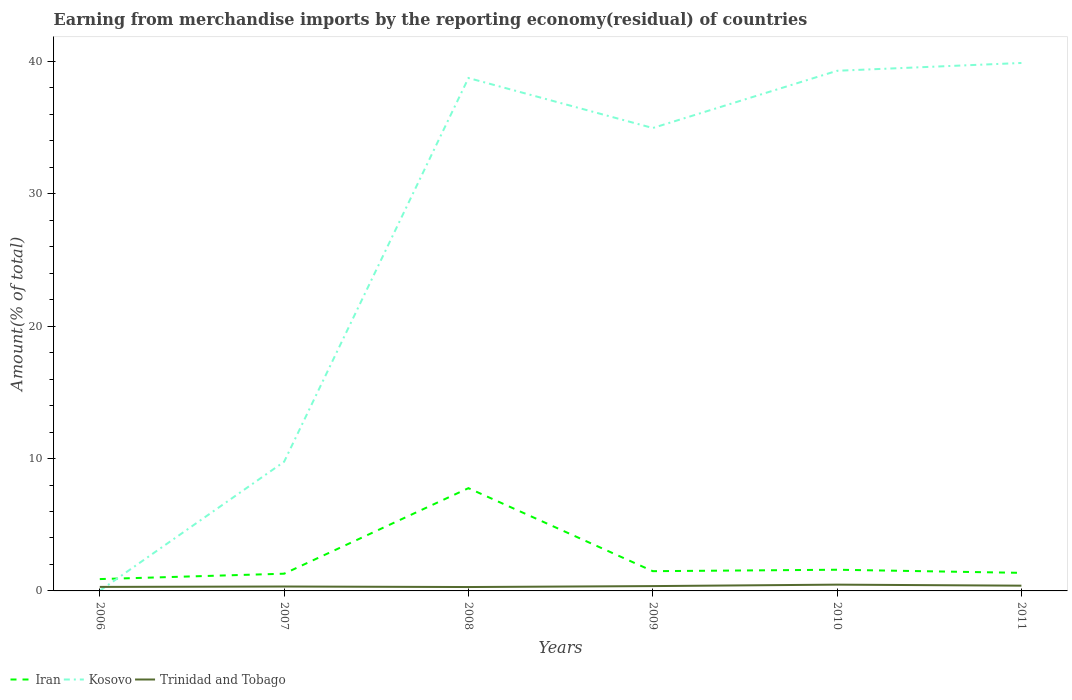Does the line corresponding to Iran intersect with the line corresponding to Trinidad and Tobago?
Offer a terse response. No. Is the number of lines equal to the number of legend labels?
Provide a short and direct response. Yes. Across all years, what is the maximum percentage of amount earned from merchandise imports in Iran?
Your answer should be very brief. 0.89. In which year was the percentage of amount earned from merchandise imports in Kosovo maximum?
Make the answer very short. 2006. What is the total percentage of amount earned from merchandise imports in Kosovo in the graph?
Offer a very short reply. -34.95. What is the difference between the highest and the second highest percentage of amount earned from merchandise imports in Kosovo?
Your answer should be compact. 39.87. How many lines are there?
Offer a very short reply. 3. What is the difference between two consecutive major ticks on the Y-axis?
Your answer should be compact. 10. Are the values on the major ticks of Y-axis written in scientific E-notation?
Offer a very short reply. No. Does the graph contain any zero values?
Your answer should be compact. No. Where does the legend appear in the graph?
Provide a short and direct response. Bottom left. What is the title of the graph?
Offer a very short reply. Earning from merchandise imports by the reporting economy(residual) of countries. Does "Dominican Republic" appear as one of the legend labels in the graph?
Give a very brief answer. No. What is the label or title of the Y-axis?
Make the answer very short. Amount(% of total). What is the Amount(% of total) of Iran in 2006?
Offer a very short reply. 0.89. What is the Amount(% of total) of Kosovo in 2006?
Give a very brief answer. 0.01. What is the Amount(% of total) of Trinidad and Tobago in 2006?
Make the answer very short. 0.3. What is the Amount(% of total) of Iran in 2007?
Offer a terse response. 1.3. What is the Amount(% of total) of Kosovo in 2007?
Your answer should be very brief. 9.76. What is the Amount(% of total) in Trinidad and Tobago in 2007?
Make the answer very short. 0.33. What is the Amount(% of total) in Iran in 2008?
Provide a succinct answer. 7.76. What is the Amount(% of total) of Kosovo in 2008?
Provide a succinct answer. 38.74. What is the Amount(% of total) of Trinidad and Tobago in 2008?
Ensure brevity in your answer.  0.29. What is the Amount(% of total) of Iran in 2009?
Your response must be concise. 1.49. What is the Amount(% of total) in Kosovo in 2009?
Offer a terse response. 34.97. What is the Amount(% of total) in Trinidad and Tobago in 2009?
Give a very brief answer. 0.36. What is the Amount(% of total) in Iran in 2010?
Offer a terse response. 1.6. What is the Amount(% of total) of Kosovo in 2010?
Give a very brief answer. 39.29. What is the Amount(% of total) of Trinidad and Tobago in 2010?
Ensure brevity in your answer.  0.47. What is the Amount(% of total) of Iran in 2011?
Your response must be concise. 1.36. What is the Amount(% of total) in Kosovo in 2011?
Keep it short and to the point. 39.88. What is the Amount(% of total) of Trinidad and Tobago in 2011?
Ensure brevity in your answer.  0.4. Across all years, what is the maximum Amount(% of total) of Iran?
Offer a terse response. 7.76. Across all years, what is the maximum Amount(% of total) of Kosovo?
Provide a short and direct response. 39.88. Across all years, what is the maximum Amount(% of total) in Trinidad and Tobago?
Your answer should be compact. 0.47. Across all years, what is the minimum Amount(% of total) in Iran?
Your answer should be very brief. 0.89. Across all years, what is the minimum Amount(% of total) of Kosovo?
Make the answer very short. 0.01. Across all years, what is the minimum Amount(% of total) in Trinidad and Tobago?
Provide a short and direct response. 0.29. What is the total Amount(% of total) in Iran in the graph?
Make the answer very short. 14.41. What is the total Amount(% of total) in Kosovo in the graph?
Your answer should be very brief. 162.65. What is the total Amount(% of total) of Trinidad and Tobago in the graph?
Your answer should be very brief. 2.17. What is the difference between the Amount(% of total) in Iran in 2006 and that in 2007?
Ensure brevity in your answer.  -0.41. What is the difference between the Amount(% of total) in Kosovo in 2006 and that in 2007?
Offer a terse response. -9.74. What is the difference between the Amount(% of total) in Trinidad and Tobago in 2006 and that in 2007?
Your response must be concise. -0.03. What is the difference between the Amount(% of total) in Iran in 2006 and that in 2008?
Give a very brief answer. -6.87. What is the difference between the Amount(% of total) of Kosovo in 2006 and that in 2008?
Offer a terse response. -38.73. What is the difference between the Amount(% of total) of Trinidad and Tobago in 2006 and that in 2008?
Your response must be concise. 0.01. What is the difference between the Amount(% of total) of Iran in 2006 and that in 2009?
Offer a very short reply. -0.6. What is the difference between the Amount(% of total) of Kosovo in 2006 and that in 2009?
Offer a terse response. -34.95. What is the difference between the Amount(% of total) in Trinidad and Tobago in 2006 and that in 2009?
Your answer should be very brief. -0.06. What is the difference between the Amount(% of total) of Iran in 2006 and that in 2010?
Ensure brevity in your answer.  -0.71. What is the difference between the Amount(% of total) of Kosovo in 2006 and that in 2010?
Offer a very short reply. -39.28. What is the difference between the Amount(% of total) in Trinidad and Tobago in 2006 and that in 2010?
Your response must be concise. -0.17. What is the difference between the Amount(% of total) in Iran in 2006 and that in 2011?
Offer a terse response. -0.47. What is the difference between the Amount(% of total) of Kosovo in 2006 and that in 2011?
Your answer should be very brief. -39.87. What is the difference between the Amount(% of total) in Trinidad and Tobago in 2006 and that in 2011?
Your answer should be compact. -0.09. What is the difference between the Amount(% of total) of Iran in 2007 and that in 2008?
Your answer should be very brief. -6.46. What is the difference between the Amount(% of total) in Kosovo in 2007 and that in 2008?
Your answer should be compact. -28.99. What is the difference between the Amount(% of total) in Trinidad and Tobago in 2007 and that in 2008?
Offer a terse response. 0.04. What is the difference between the Amount(% of total) of Iran in 2007 and that in 2009?
Your response must be concise. -0.19. What is the difference between the Amount(% of total) in Kosovo in 2007 and that in 2009?
Make the answer very short. -25.21. What is the difference between the Amount(% of total) of Trinidad and Tobago in 2007 and that in 2009?
Provide a short and direct response. -0.03. What is the difference between the Amount(% of total) of Iran in 2007 and that in 2010?
Offer a terse response. -0.3. What is the difference between the Amount(% of total) of Kosovo in 2007 and that in 2010?
Keep it short and to the point. -29.53. What is the difference between the Amount(% of total) in Trinidad and Tobago in 2007 and that in 2010?
Provide a short and direct response. -0.14. What is the difference between the Amount(% of total) in Iran in 2007 and that in 2011?
Offer a terse response. -0.06. What is the difference between the Amount(% of total) in Kosovo in 2007 and that in 2011?
Ensure brevity in your answer.  -30.12. What is the difference between the Amount(% of total) in Trinidad and Tobago in 2007 and that in 2011?
Your response must be concise. -0.06. What is the difference between the Amount(% of total) of Iran in 2008 and that in 2009?
Your response must be concise. 6.27. What is the difference between the Amount(% of total) of Kosovo in 2008 and that in 2009?
Offer a very short reply. 3.78. What is the difference between the Amount(% of total) of Trinidad and Tobago in 2008 and that in 2009?
Provide a succinct answer. -0.07. What is the difference between the Amount(% of total) of Iran in 2008 and that in 2010?
Give a very brief answer. 6.16. What is the difference between the Amount(% of total) in Kosovo in 2008 and that in 2010?
Keep it short and to the point. -0.55. What is the difference between the Amount(% of total) of Trinidad and Tobago in 2008 and that in 2010?
Provide a succinct answer. -0.18. What is the difference between the Amount(% of total) in Iran in 2008 and that in 2011?
Provide a short and direct response. 6.4. What is the difference between the Amount(% of total) in Kosovo in 2008 and that in 2011?
Provide a succinct answer. -1.14. What is the difference between the Amount(% of total) of Trinidad and Tobago in 2008 and that in 2011?
Your response must be concise. -0.1. What is the difference between the Amount(% of total) in Iran in 2009 and that in 2010?
Your answer should be very brief. -0.11. What is the difference between the Amount(% of total) of Kosovo in 2009 and that in 2010?
Give a very brief answer. -4.32. What is the difference between the Amount(% of total) of Trinidad and Tobago in 2009 and that in 2010?
Keep it short and to the point. -0.11. What is the difference between the Amount(% of total) in Iran in 2009 and that in 2011?
Offer a very short reply. 0.13. What is the difference between the Amount(% of total) in Kosovo in 2009 and that in 2011?
Make the answer very short. -4.91. What is the difference between the Amount(% of total) of Trinidad and Tobago in 2009 and that in 2011?
Ensure brevity in your answer.  -0.03. What is the difference between the Amount(% of total) of Iran in 2010 and that in 2011?
Offer a very short reply. 0.24. What is the difference between the Amount(% of total) of Kosovo in 2010 and that in 2011?
Make the answer very short. -0.59. What is the difference between the Amount(% of total) of Trinidad and Tobago in 2010 and that in 2011?
Give a very brief answer. 0.08. What is the difference between the Amount(% of total) of Iran in 2006 and the Amount(% of total) of Kosovo in 2007?
Keep it short and to the point. -8.86. What is the difference between the Amount(% of total) of Iran in 2006 and the Amount(% of total) of Trinidad and Tobago in 2007?
Your answer should be very brief. 0.56. What is the difference between the Amount(% of total) in Kosovo in 2006 and the Amount(% of total) in Trinidad and Tobago in 2007?
Keep it short and to the point. -0.32. What is the difference between the Amount(% of total) in Iran in 2006 and the Amount(% of total) in Kosovo in 2008?
Provide a short and direct response. -37.85. What is the difference between the Amount(% of total) in Iran in 2006 and the Amount(% of total) in Trinidad and Tobago in 2008?
Your answer should be very brief. 0.6. What is the difference between the Amount(% of total) of Kosovo in 2006 and the Amount(% of total) of Trinidad and Tobago in 2008?
Provide a short and direct response. -0.28. What is the difference between the Amount(% of total) of Iran in 2006 and the Amount(% of total) of Kosovo in 2009?
Your answer should be compact. -34.07. What is the difference between the Amount(% of total) of Iran in 2006 and the Amount(% of total) of Trinidad and Tobago in 2009?
Offer a very short reply. 0.53. What is the difference between the Amount(% of total) of Kosovo in 2006 and the Amount(% of total) of Trinidad and Tobago in 2009?
Provide a short and direct response. -0.35. What is the difference between the Amount(% of total) in Iran in 2006 and the Amount(% of total) in Kosovo in 2010?
Give a very brief answer. -38.4. What is the difference between the Amount(% of total) of Iran in 2006 and the Amount(% of total) of Trinidad and Tobago in 2010?
Provide a short and direct response. 0.42. What is the difference between the Amount(% of total) of Kosovo in 2006 and the Amount(% of total) of Trinidad and Tobago in 2010?
Provide a succinct answer. -0.46. What is the difference between the Amount(% of total) in Iran in 2006 and the Amount(% of total) in Kosovo in 2011?
Your answer should be very brief. -38.99. What is the difference between the Amount(% of total) of Iran in 2006 and the Amount(% of total) of Trinidad and Tobago in 2011?
Provide a short and direct response. 0.5. What is the difference between the Amount(% of total) of Kosovo in 2006 and the Amount(% of total) of Trinidad and Tobago in 2011?
Provide a succinct answer. -0.38. What is the difference between the Amount(% of total) of Iran in 2007 and the Amount(% of total) of Kosovo in 2008?
Provide a short and direct response. -37.44. What is the difference between the Amount(% of total) of Kosovo in 2007 and the Amount(% of total) of Trinidad and Tobago in 2008?
Give a very brief answer. 9.46. What is the difference between the Amount(% of total) in Iran in 2007 and the Amount(% of total) in Kosovo in 2009?
Give a very brief answer. -33.67. What is the difference between the Amount(% of total) in Iran in 2007 and the Amount(% of total) in Trinidad and Tobago in 2009?
Give a very brief answer. 0.94. What is the difference between the Amount(% of total) of Kosovo in 2007 and the Amount(% of total) of Trinidad and Tobago in 2009?
Make the answer very short. 9.39. What is the difference between the Amount(% of total) of Iran in 2007 and the Amount(% of total) of Kosovo in 2010?
Give a very brief answer. -37.99. What is the difference between the Amount(% of total) of Iran in 2007 and the Amount(% of total) of Trinidad and Tobago in 2010?
Your answer should be very brief. 0.83. What is the difference between the Amount(% of total) in Kosovo in 2007 and the Amount(% of total) in Trinidad and Tobago in 2010?
Your answer should be compact. 9.28. What is the difference between the Amount(% of total) in Iran in 2007 and the Amount(% of total) in Kosovo in 2011?
Your answer should be compact. -38.58. What is the difference between the Amount(% of total) in Iran in 2007 and the Amount(% of total) in Trinidad and Tobago in 2011?
Your answer should be compact. 0.9. What is the difference between the Amount(% of total) of Kosovo in 2007 and the Amount(% of total) of Trinidad and Tobago in 2011?
Your answer should be compact. 9.36. What is the difference between the Amount(% of total) in Iran in 2008 and the Amount(% of total) in Kosovo in 2009?
Ensure brevity in your answer.  -27.2. What is the difference between the Amount(% of total) in Iran in 2008 and the Amount(% of total) in Trinidad and Tobago in 2009?
Your answer should be compact. 7.4. What is the difference between the Amount(% of total) in Kosovo in 2008 and the Amount(% of total) in Trinidad and Tobago in 2009?
Make the answer very short. 38.38. What is the difference between the Amount(% of total) of Iran in 2008 and the Amount(% of total) of Kosovo in 2010?
Make the answer very short. -31.53. What is the difference between the Amount(% of total) in Iran in 2008 and the Amount(% of total) in Trinidad and Tobago in 2010?
Ensure brevity in your answer.  7.29. What is the difference between the Amount(% of total) of Kosovo in 2008 and the Amount(% of total) of Trinidad and Tobago in 2010?
Provide a succinct answer. 38.27. What is the difference between the Amount(% of total) of Iran in 2008 and the Amount(% of total) of Kosovo in 2011?
Give a very brief answer. -32.12. What is the difference between the Amount(% of total) of Iran in 2008 and the Amount(% of total) of Trinidad and Tobago in 2011?
Your answer should be compact. 7.37. What is the difference between the Amount(% of total) of Kosovo in 2008 and the Amount(% of total) of Trinidad and Tobago in 2011?
Give a very brief answer. 38.35. What is the difference between the Amount(% of total) in Iran in 2009 and the Amount(% of total) in Kosovo in 2010?
Offer a very short reply. -37.8. What is the difference between the Amount(% of total) of Iran in 2009 and the Amount(% of total) of Trinidad and Tobago in 2010?
Offer a terse response. 1.02. What is the difference between the Amount(% of total) in Kosovo in 2009 and the Amount(% of total) in Trinidad and Tobago in 2010?
Provide a succinct answer. 34.49. What is the difference between the Amount(% of total) of Iran in 2009 and the Amount(% of total) of Kosovo in 2011?
Your answer should be very brief. -38.39. What is the difference between the Amount(% of total) in Iran in 2009 and the Amount(% of total) in Trinidad and Tobago in 2011?
Make the answer very short. 1.09. What is the difference between the Amount(% of total) in Kosovo in 2009 and the Amount(% of total) in Trinidad and Tobago in 2011?
Give a very brief answer. 34.57. What is the difference between the Amount(% of total) in Iran in 2010 and the Amount(% of total) in Kosovo in 2011?
Your response must be concise. -38.28. What is the difference between the Amount(% of total) in Iran in 2010 and the Amount(% of total) in Trinidad and Tobago in 2011?
Make the answer very short. 1.2. What is the difference between the Amount(% of total) of Kosovo in 2010 and the Amount(% of total) of Trinidad and Tobago in 2011?
Your answer should be compact. 38.89. What is the average Amount(% of total) of Iran per year?
Make the answer very short. 2.4. What is the average Amount(% of total) in Kosovo per year?
Your response must be concise. 27.11. What is the average Amount(% of total) in Trinidad and Tobago per year?
Give a very brief answer. 0.36. In the year 2006, what is the difference between the Amount(% of total) in Iran and Amount(% of total) in Kosovo?
Your answer should be very brief. 0.88. In the year 2006, what is the difference between the Amount(% of total) in Iran and Amount(% of total) in Trinidad and Tobago?
Your answer should be very brief. 0.59. In the year 2006, what is the difference between the Amount(% of total) in Kosovo and Amount(% of total) in Trinidad and Tobago?
Keep it short and to the point. -0.29. In the year 2007, what is the difference between the Amount(% of total) of Iran and Amount(% of total) of Kosovo?
Provide a short and direct response. -8.46. In the year 2007, what is the difference between the Amount(% of total) in Kosovo and Amount(% of total) in Trinidad and Tobago?
Your answer should be very brief. 9.42. In the year 2008, what is the difference between the Amount(% of total) of Iran and Amount(% of total) of Kosovo?
Your answer should be very brief. -30.98. In the year 2008, what is the difference between the Amount(% of total) in Iran and Amount(% of total) in Trinidad and Tobago?
Offer a very short reply. 7.47. In the year 2008, what is the difference between the Amount(% of total) in Kosovo and Amount(% of total) in Trinidad and Tobago?
Keep it short and to the point. 38.45. In the year 2009, what is the difference between the Amount(% of total) of Iran and Amount(% of total) of Kosovo?
Ensure brevity in your answer.  -33.47. In the year 2009, what is the difference between the Amount(% of total) of Iran and Amount(% of total) of Trinidad and Tobago?
Provide a short and direct response. 1.13. In the year 2009, what is the difference between the Amount(% of total) in Kosovo and Amount(% of total) in Trinidad and Tobago?
Give a very brief answer. 34.6. In the year 2010, what is the difference between the Amount(% of total) in Iran and Amount(% of total) in Kosovo?
Your answer should be compact. -37.69. In the year 2010, what is the difference between the Amount(% of total) in Iran and Amount(% of total) in Trinidad and Tobago?
Your response must be concise. 1.13. In the year 2010, what is the difference between the Amount(% of total) in Kosovo and Amount(% of total) in Trinidad and Tobago?
Your answer should be very brief. 38.81. In the year 2011, what is the difference between the Amount(% of total) of Iran and Amount(% of total) of Kosovo?
Provide a succinct answer. -38.52. In the year 2011, what is the difference between the Amount(% of total) of Iran and Amount(% of total) of Trinidad and Tobago?
Give a very brief answer. 0.97. In the year 2011, what is the difference between the Amount(% of total) in Kosovo and Amount(% of total) in Trinidad and Tobago?
Keep it short and to the point. 39.48. What is the ratio of the Amount(% of total) of Iran in 2006 to that in 2007?
Ensure brevity in your answer.  0.69. What is the ratio of the Amount(% of total) in Kosovo in 2006 to that in 2007?
Keep it short and to the point. 0. What is the ratio of the Amount(% of total) in Trinidad and Tobago in 2006 to that in 2007?
Make the answer very short. 0.91. What is the ratio of the Amount(% of total) in Iran in 2006 to that in 2008?
Your answer should be very brief. 0.12. What is the ratio of the Amount(% of total) of Trinidad and Tobago in 2006 to that in 2008?
Offer a very short reply. 1.03. What is the ratio of the Amount(% of total) of Iran in 2006 to that in 2009?
Give a very brief answer. 0.6. What is the ratio of the Amount(% of total) of Kosovo in 2006 to that in 2009?
Keep it short and to the point. 0. What is the ratio of the Amount(% of total) in Trinidad and Tobago in 2006 to that in 2009?
Provide a short and direct response. 0.83. What is the ratio of the Amount(% of total) in Iran in 2006 to that in 2010?
Provide a succinct answer. 0.56. What is the ratio of the Amount(% of total) in Kosovo in 2006 to that in 2010?
Keep it short and to the point. 0. What is the ratio of the Amount(% of total) in Trinidad and Tobago in 2006 to that in 2010?
Offer a terse response. 0.64. What is the ratio of the Amount(% of total) of Iran in 2006 to that in 2011?
Provide a short and direct response. 0.66. What is the ratio of the Amount(% of total) in Kosovo in 2006 to that in 2011?
Make the answer very short. 0. What is the ratio of the Amount(% of total) of Trinidad and Tobago in 2006 to that in 2011?
Provide a short and direct response. 0.76. What is the ratio of the Amount(% of total) in Iran in 2007 to that in 2008?
Offer a very short reply. 0.17. What is the ratio of the Amount(% of total) in Kosovo in 2007 to that in 2008?
Give a very brief answer. 0.25. What is the ratio of the Amount(% of total) in Trinidad and Tobago in 2007 to that in 2008?
Give a very brief answer. 1.13. What is the ratio of the Amount(% of total) of Iran in 2007 to that in 2009?
Offer a terse response. 0.87. What is the ratio of the Amount(% of total) in Kosovo in 2007 to that in 2009?
Your answer should be very brief. 0.28. What is the ratio of the Amount(% of total) of Trinidad and Tobago in 2007 to that in 2009?
Ensure brevity in your answer.  0.91. What is the ratio of the Amount(% of total) in Iran in 2007 to that in 2010?
Your answer should be compact. 0.81. What is the ratio of the Amount(% of total) in Kosovo in 2007 to that in 2010?
Make the answer very short. 0.25. What is the ratio of the Amount(% of total) of Trinidad and Tobago in 2007 to that in 2010?
Give a very brief answer. 0.7. What is the ratio of the Amount(% of total) of Iran in 2007 to that in 2011?
Your answer should be very brief. 0.95. What is the ratio of the Amount(% of total) of Kosovo in 2007 to that in 2011?
Make the answer very short. 0.24. What is the ratio of the Amount(% of total) of Trinidad and Tobago in 2007 to that in 2011?
Keep it short and to the point. 0.84. What is the ratio of the Amount(% of total) in Iran in 2008 to that in 2009?
Keep it short and to the point. 5.2. What is the ratio of the Amount(% of total) of Kosovo in 2008 to that in 2009?
Offer a terse response. 1.11. What is the ratio of the Amount(% of total) of Trinidad and Tobago in 2008 to that in 2009?
Your answer should be very brief. 0.81. What is the ratio of the Amount(% of total) of Iran in 2008 to that in 2010?
Ensure brevity in your answer.  4.85. What is the ratio of the Amount(% of total) of Kosovo in 2008 to that in 2010?
Offer a very short reply. 0.99. What is the ratio of the Amount(% of total) in Trinidad and Tobago in 2008 to that in 2010?
Your answer should be compact. 0.62. What is the ratio of the Amount(% of total) in Iran in 2008 to that in 2011?
Ensure brevity in your answer.  5.69. What is the ratio of the Amount(% of total) of Kosovo in 2008 to that in 2011?
Offer a very short reply. 0.97. What is the ratio of the Amount(% of total) in Trinidad and Tobago in 2008 to that in 2011?
Give a very brief answer. 0.74. What is the ratio of the Amount(% of total) of Iran in 2009 to that in 2010?
Your answer should be very brief. 0.93. What is the ratio of the Amount(% of total) of Kosovo in 2009 to that in 2010?
Offer a terse response. 0.89. What is the ratio of the Amount(% of total) in Trinidad and Tobago in 2009 to that in 2010?
Your answer should be very brief. 0.77. What is the ratio of the Amount(% of total) in Iran in 2009 to that in 2011?
Offer a very short reply. 1.09. What is the ratio of the Amount(% of total) of Kosovo in 2009 to that in 2011?
Provide a short and direct response. 0.88. What is the ratio of the Amount(% of total) in Trinidad and Tobago in 2009 to that in 2011?
Offer a very short reply. 0.92. What is the ratio of the Amount(% of total) in Iran in 2010 to that in 2011?
Provide a succinct answer. 1.17. What is the ratio of the Amount(% of total) of Kosovo in 2010 to that in 2011?
Offer a terse response. 0.99. What is the ratio of the Amount(% of total) in Trinidad and Tobago in 2010 to that in 2011?
Your response must be concise. 1.2. What is the difference between the highest and the second highest Amount(% of total) of Iran?
Your answer should be very brief. 6.16. What is the difference between the highest and the second highest Amount(% of total) in Kosovo?
Offer a terse response. 0.59. What is the difference between the highest and the second highest Amount(% of total) in Trinidad and Tobago?
Give a very brief answer. 0.08. What is the difference between the highest and the lowest Amount(% of total) of Iran?
Provide a succinct answer. 6.87. What is the difference between the highest and the lowest Amount(% of total) of Kosovo?
Offer a very short reply. 39.87. What is the difference between the highest and the lowest Amount(% of total) of Trinidad and Tobago?
Give a very brief answer. 0.18. 